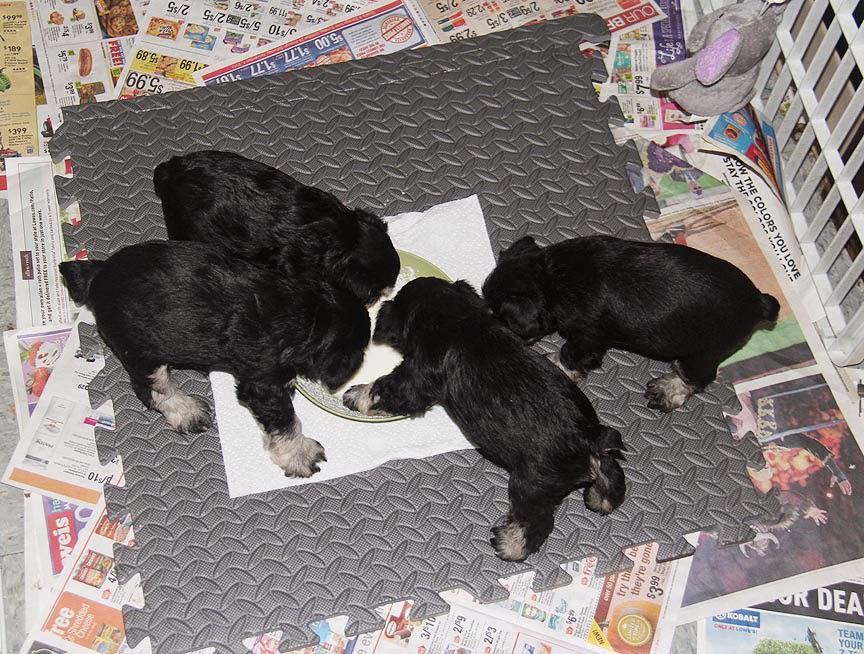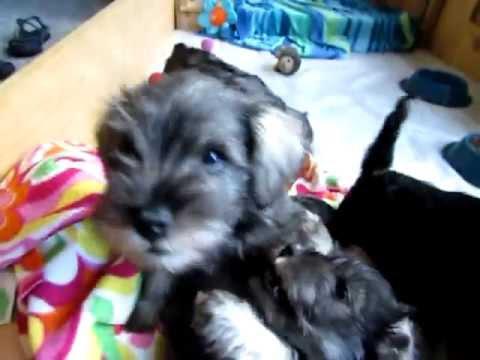The first image is the image on the left, the second image is the image on the right. Evaluate the accuracy of this statement regarding the images: "there are puppies in a wooden box". Is it true? Answer yes or no. No. The first image is the image on the left, the second image is the image on the right. Given the left and right images, does the statement "At least one puppy has white hair around it's mouth." hold true? Answer yes or no. Yes. The first image is the image on the left, the second image is the image on the right. Evaluate the accuracy of this statement regarding the images: "At least one image in the set features 4 or more puppies, laying with their mother.". Is it true? Answer yes or no. No. The first image is the image on the left, the second image is the image on the right. Evaluate the accuracy of this statement regarding the images: "There are four or more puppies sleeping together in each image". Is it true? Answer yes or no. No. 